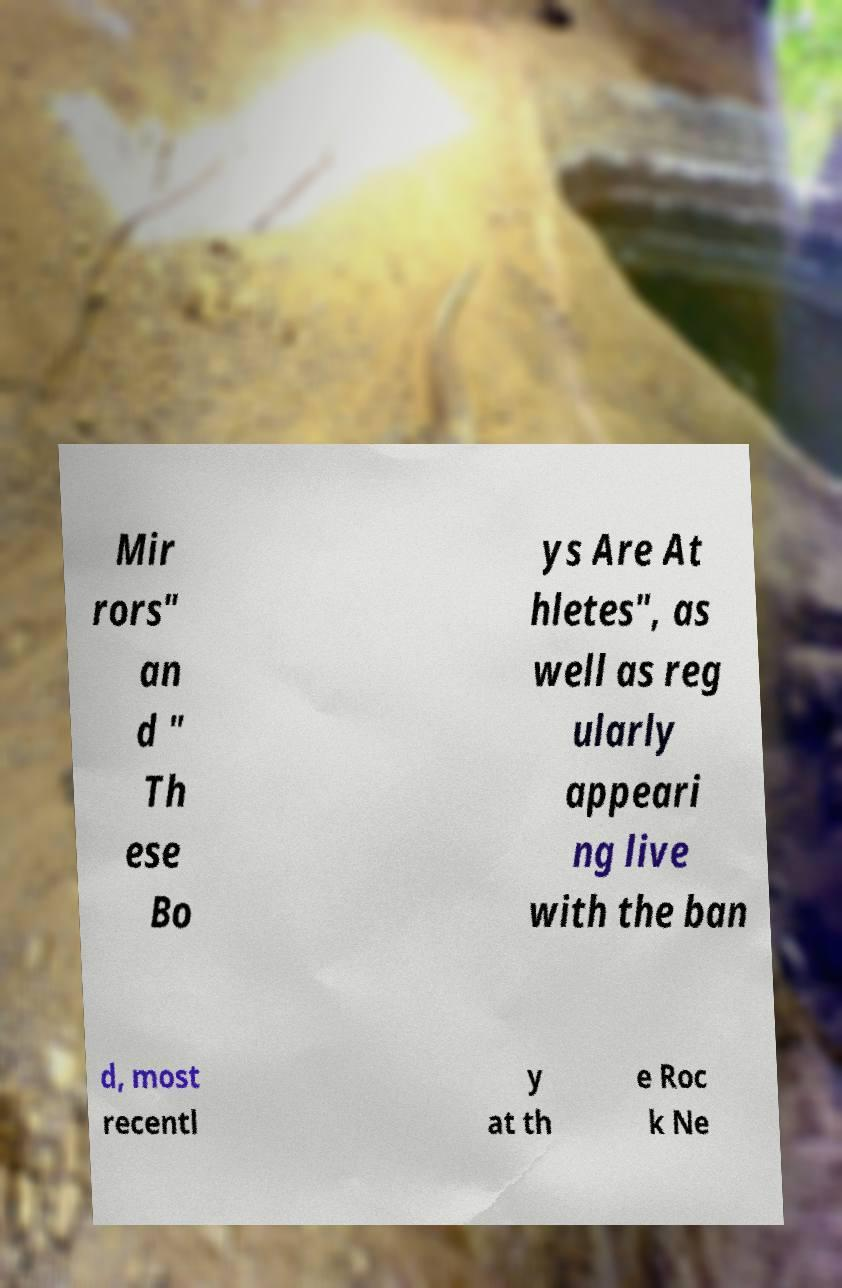There's text embedded in this image that I need extracted. Can you transcribe it verbatim? Mir rors" an d " Th ese Bo ys Are At hletes", as well as reg ularly appeari ng live with the ban d, most recentl y at th e Roc k Ne 